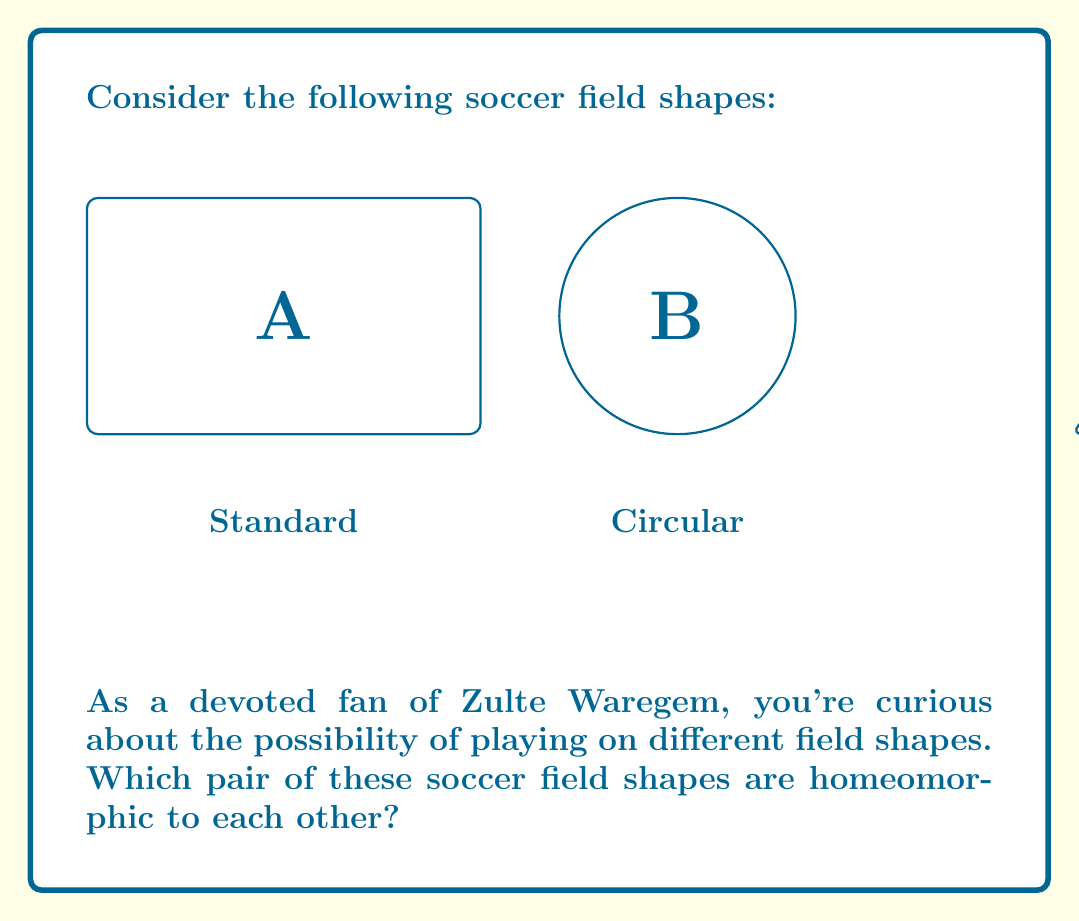Can you answer this question? To determine which pair of soccer field shapes are homeomorphic, we need to consider the topological properties of each shape:

1. Standard rectangular field (A): This is topologically equivalent to a disk. It has no holes and a continuous boundary.

2. Circular field (B): This is also topologically equivalent to a disk. Like the rectangle, it has no holes and a continuous boundary.

3. Triangular field (C): This too is topologically equivalent to a disk. It has no holes and a continuous boundary.

In topology, two spaces are considered homeomorphic if there exists a continuous function between them with a continuous inverse. This means that one shape can be continuously deformed into the other without cutting, tearing, or gluing.

Key points to consider:

a) All three shapes have no holes.
b) All three shapes have a single continuous boundary.
c) The corners of the rectangle and triangle do not affect their topological properties.

Therefore, all three shapes are actually homeomorphic to each other. They can all be continuously deformed into one another without changing their fundamental topological properties.

However, the question asks for a pair. Any pair chosen from these three shapes will be homeomorphic. For example, we can say that the standard rectangular field (A) and the circular field (B) are homeomorphic.

The homeomorphism between A and B can be visualized as stretching the corners of the rectangle outward to form a circle, or conversely, pushing the sides of the circle inward to form a rectangle.
Answer: A and B (Standard rectangular and circular fields) 